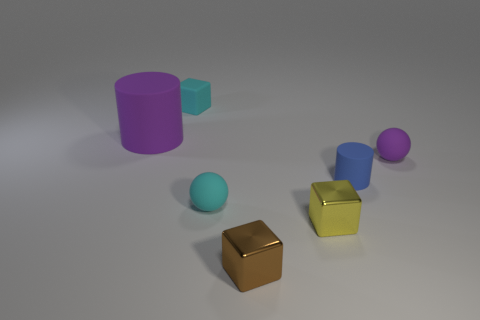Subtract all tiny metallic cubes. How many cubes are left? 1 Add 1 small matte blocks. How many objects exist? 8 Subtract all purple cylinders. How many cylinders are left? 1 Subtract all cubes. How many objects are left? 4 Subtract all big red cubes. Subtract all purple balls. How many objects are left? 6 Add 7 large matte objects. How many large matte objects are left? 8 Add 3 big cyan balls. How many big cyan balls exist? 3 Subtract 0 red balls. How many objects are left? 7 Subtract 2 cubes. How many cubes are left? 1 Subtract all brown cubes. Subtract all blue spheres. How many cubes are left? 2 